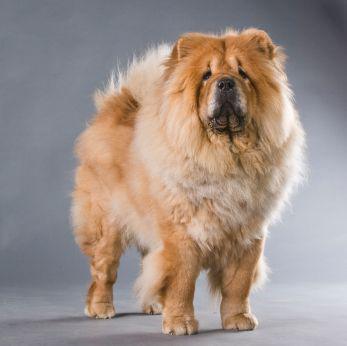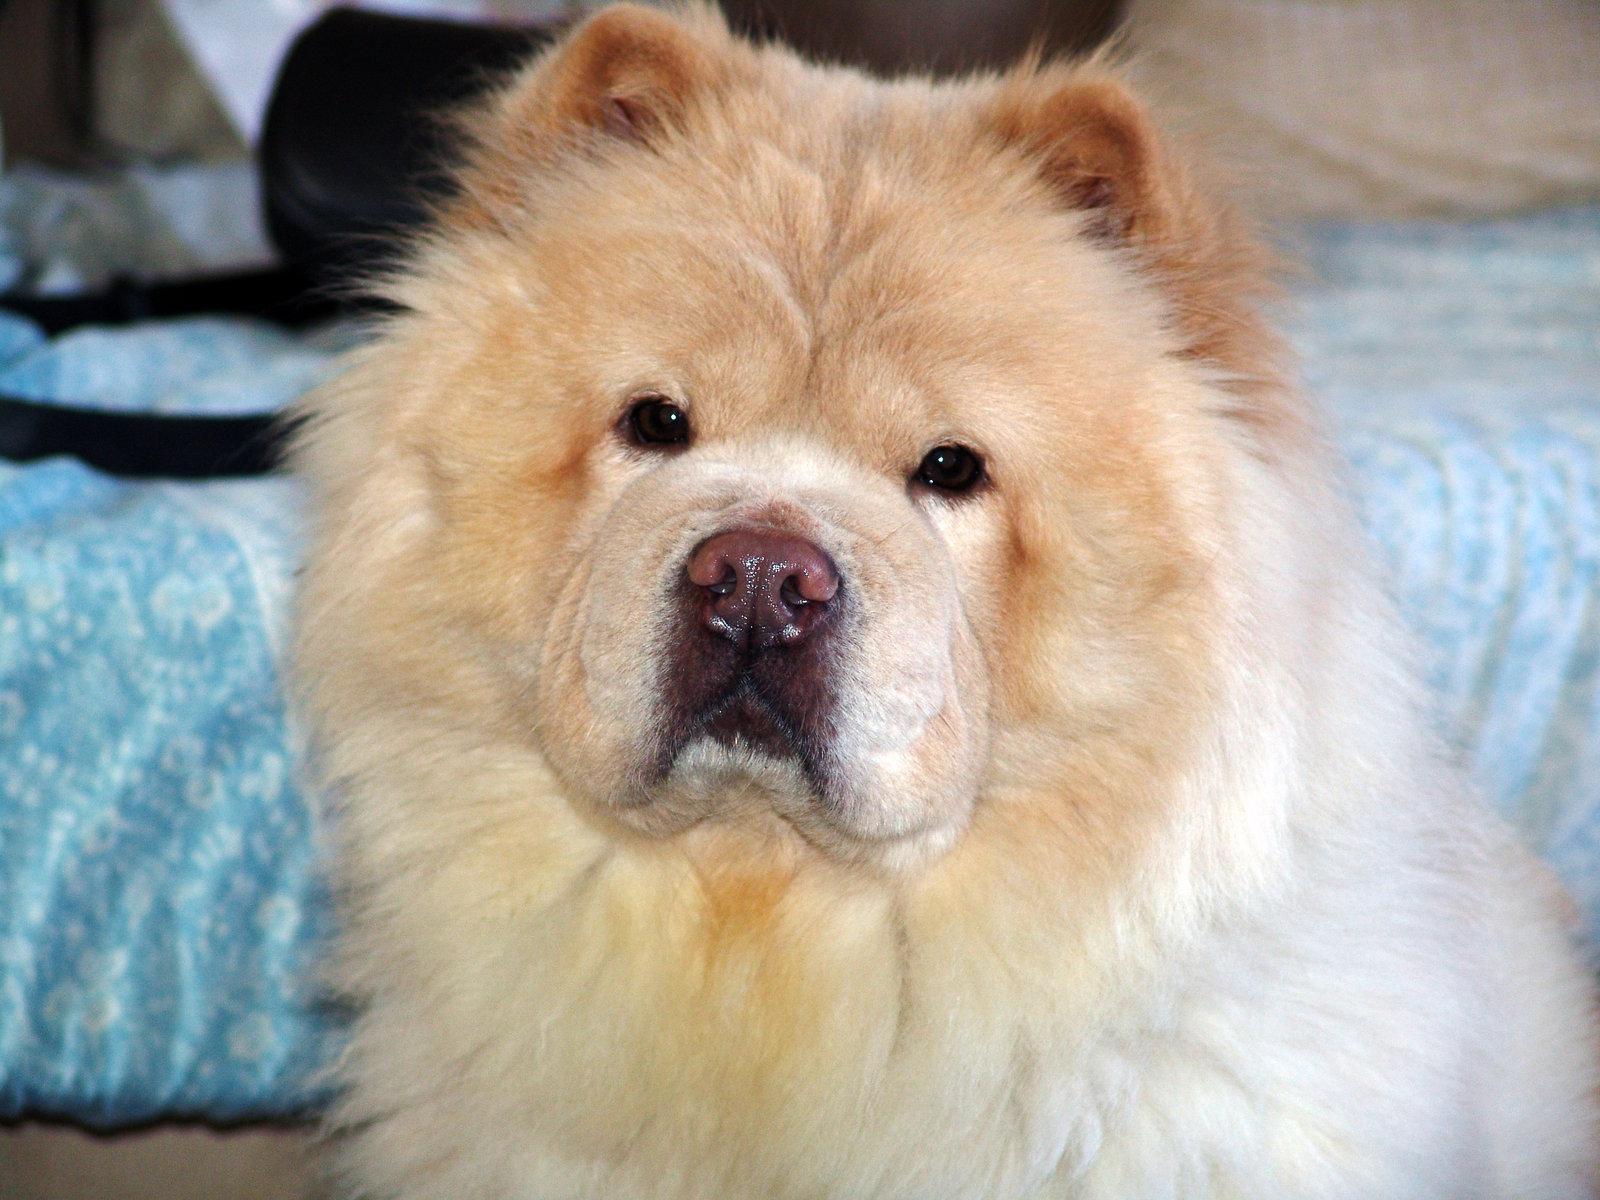The first image is the image on the left, the second image is the image on the right. Examine the images to the left and right. Is the description "The dog in the image on the right has its mouth open" accurate? Answer yes or no. No. 